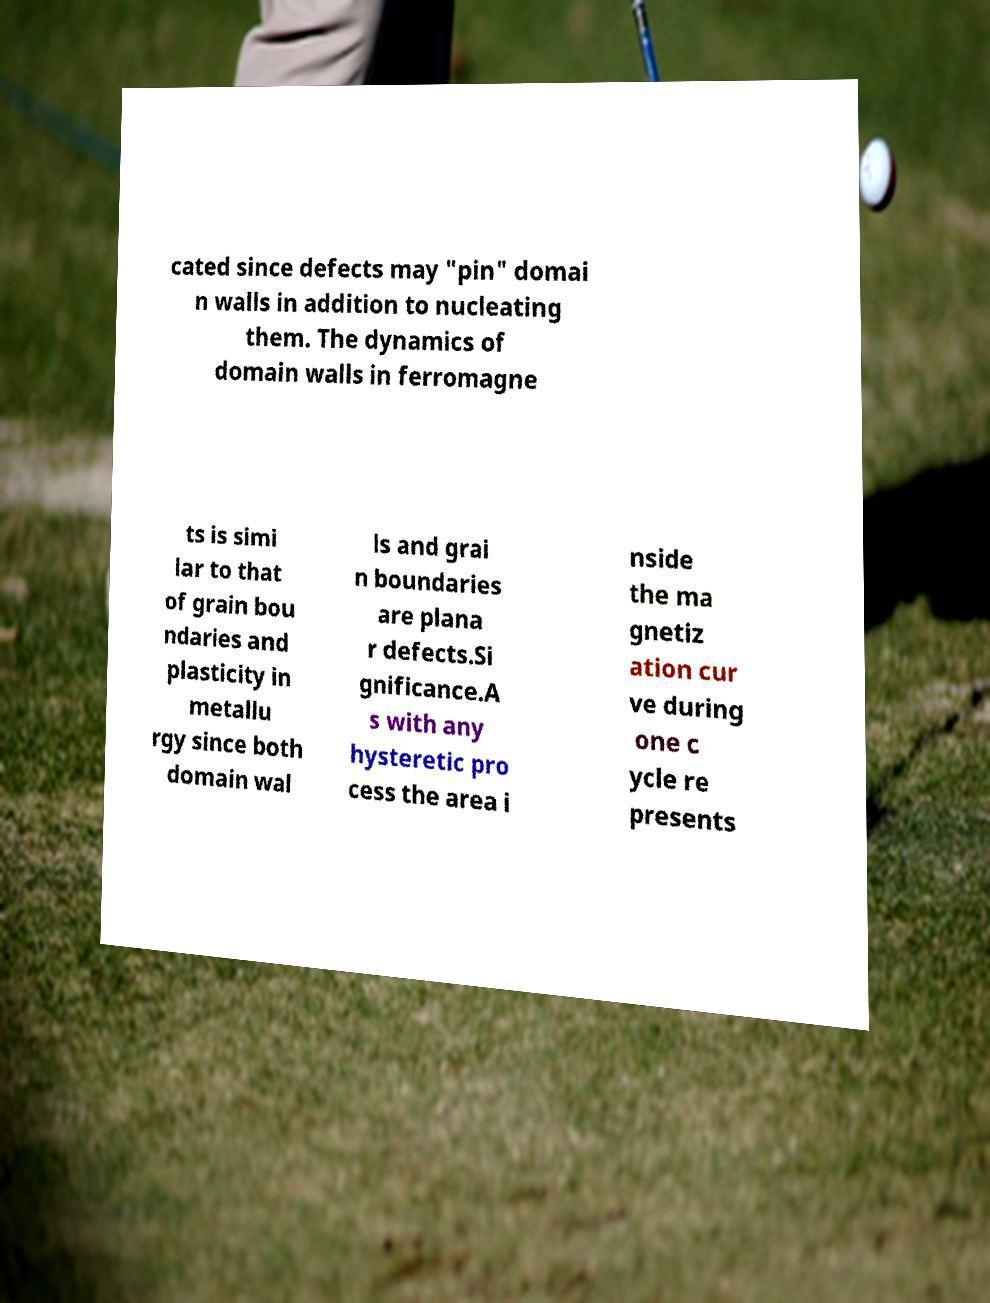I need the written content from this picture converted into text. Can you do that? cated since defects may "pin" domai n walls in addition to nucleating them. The dynamics of domain walls in ferromagne ts is simi lar to that of grain bou ndaries and plasticity in metallu rgy since both domain wal ls and grai n boundaries are plana r defects.Si gnificance.A s with any hysteretic pro cess the area i nside the ma gnetiz ation cur ve during one c ycle re presents 